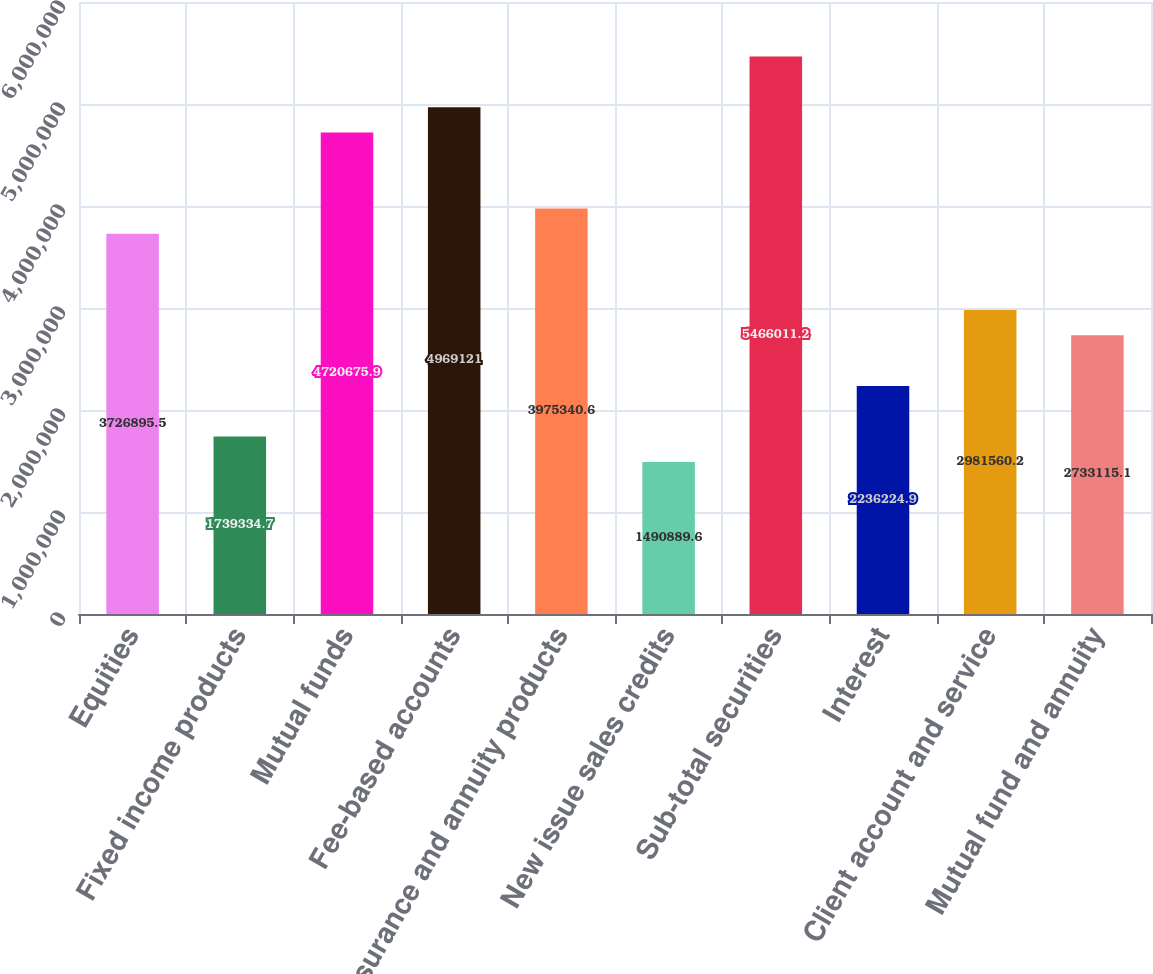<chart> <loc_0><loc_0><loc_500><loc_500><bar_chart><fcel>Equities<fcel>Fixed income products<fcel>Mutual funds<fcel>Fee-based accounts<fcel>Insurance and annuity products<fcel>New issue sales credits<fcel>Sub-total securities<fcel>Interest<fcel>Client account and service<fcel>Mutual fund and annuity<nl><fcel>3.7269e+06<fcel>1.73933e+06<fcel>4.72068e+06<fcel>4.96912e+06<fcel>3.97534e+06<fcel>1.49089e+06<fcel>5.46601e+06<fcel>2.23622e+06<fcel>2.98156e+06<fcel>2.73312e+06<nl></chart> 